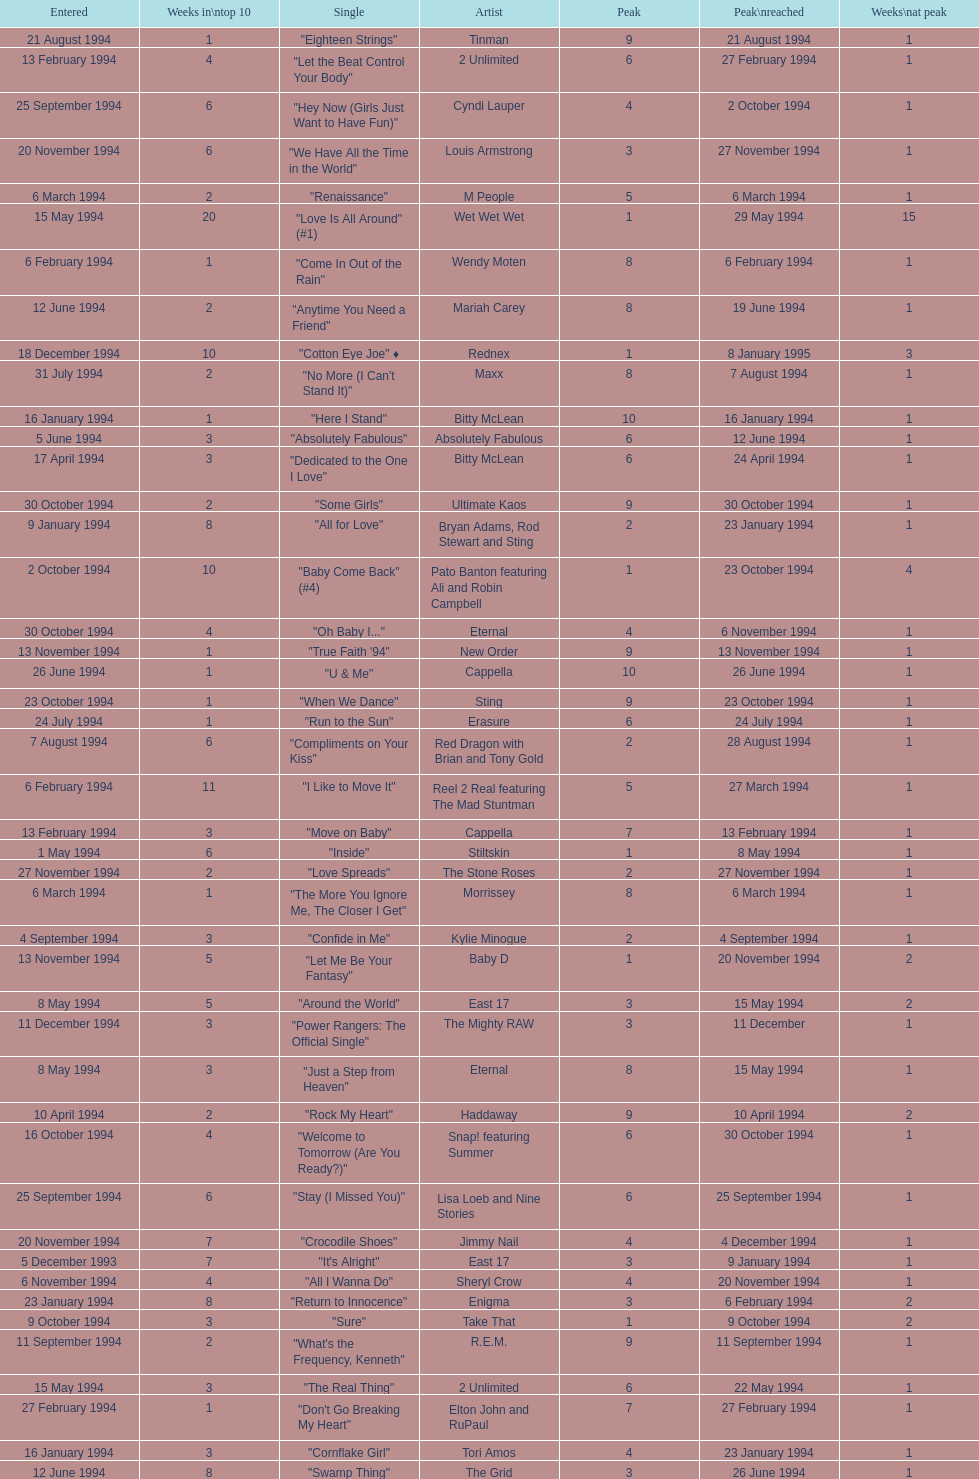Which artist only has its single entered on 2 january 1994? D:Ream. 